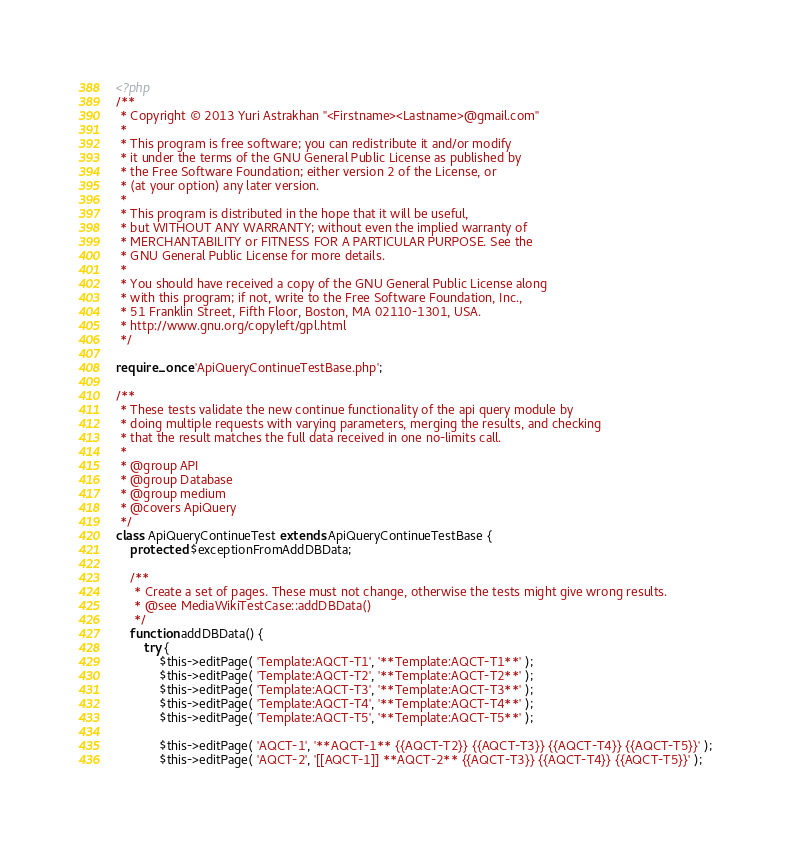<code> <loc_0><loc_0><loc_500><loc_500><_PHP_><?php
/**
 * Copyright © 2013 Yuri Astrakhan "<Firstname><Lastname>@gmail.com"
 *
 * This program is free software; you can redistribute it and/or modify
 * it under the terms of the GNU General Public License as published by
 * the Free Software Foundation; either version 2 of the License, or
 * (at your option) any later version.
 *
 * This program is distributed in the hope that it will be useful,
 * but WITHOUT ANY WARRANTY; without even the implied warranty of
 * MERCHANTABILITY or FITNESS FOR A PARTICULAR PURPOSE. See the
 * GNU General Public License for more details.
 *
 * You should have received a copy of the GNU General Public License along
 * with this program; if not, write to the Free Software Foundation, Inc.,
 * 51 Franklin Street, Fifth Floor, Boston, MA 02110-1301, USA.
 * http://www.gnu.org/copyleft/gpl.html
 */

require_once 'ApiQueryContinueTestBase.php';

/**
 * These tests validate the new continue functionality of the api query module by
 * doing multiple requests with varying parameters, merging the results, and checking
 * that the result matches the full data received in one no-limits call.
 *
 * @group API
 * @group Database
 * @group medium
 * @covers ApiQuery
 */
class ApiQueryContinueTest extends ApiQueryContinueTestBase {
	protected $exceptionFromAddDBData;

	/**
	 * Create a set of pages. These must not change, otherwise the tests might give wrong results.
	 * @see MediaWikiTestCase::addDBData()
	 */
	function addDBData() {
		try {
			$this->editPage( 'Template:AQCT-T1', '**Template:AQCT-T1**' );
			$this->editPage( 'Template:AQCT-T2', '**Template:AQCT-T2**' );
			$this->editPage( 'Template:AQCT-T3', '**Template:AQCT-T3**' );
			$this->editPage( 'Template:AQCT-T4', '**Template:AQCT-T4**' );
			$this->editPage( 'Template:AQCT-T5', '**Template:AQCT-T5**' );

			$this->editPage( 'AQCT-1', '**AQCT-1** {{AQCT-T2}} {{AQCT-T3}} {{AQCT-T4}} {{AQCT-T5}}' );
			$this->editPage( 'AQCT-2', '[[AQCT-1]] **AQCT-2** {{AQCT-T3}} {{AQCT-T4}} {{AQCT-T5}}' );</code> 